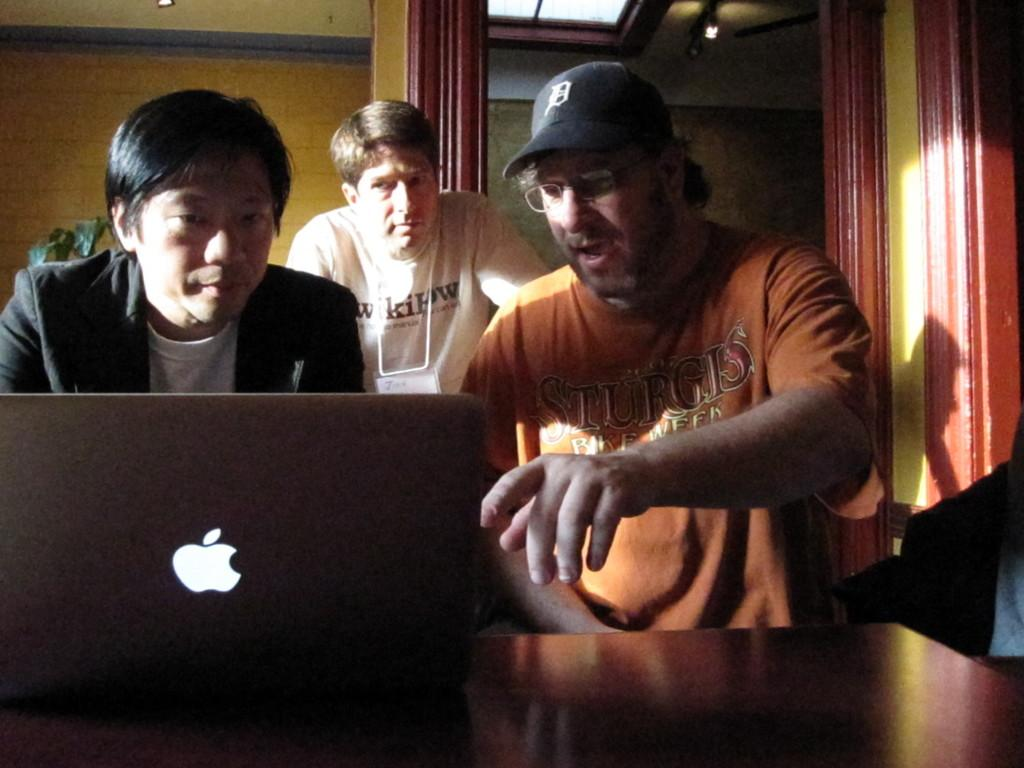How many people are present in the image? There are three people in the image. What object can be seen on a table in the image? There is a laptop on a table in the image. What type of decoration is present on the roof in the image? There are light arrangements on the roof in the image. Where is the basket hanging in the image? There is no basket present in the image. Can you see a swing in the image? There is no swing present in the image. 